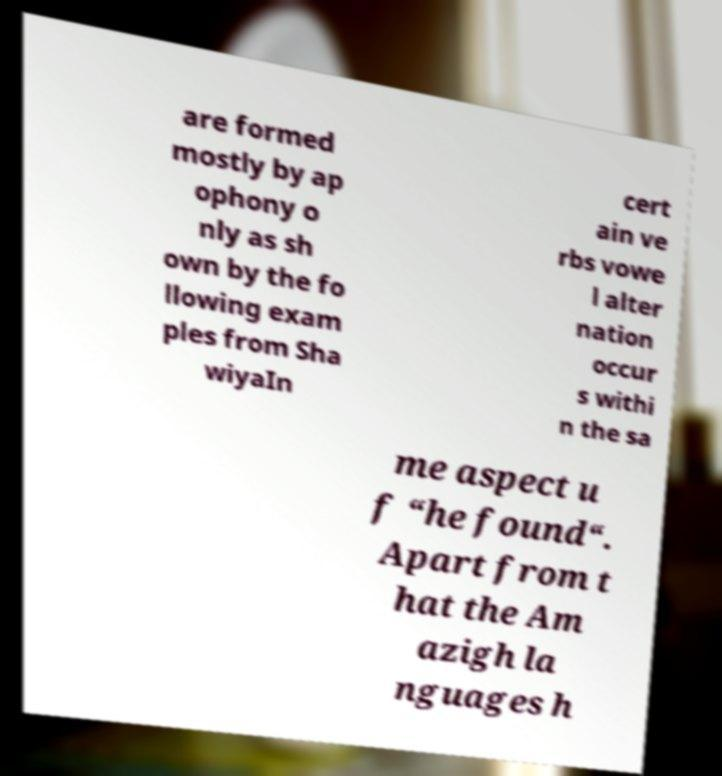Could you extract and type out the text from this image? are formed mostly by ap ophony o nly as sh own by the fo llowing exam ples from Sha wiyaIn cert ain ve rbs vowe l alter nation occur s withi n the sa me aspect u f “he found“. Apart from t hat the Am azigh la nguages h 